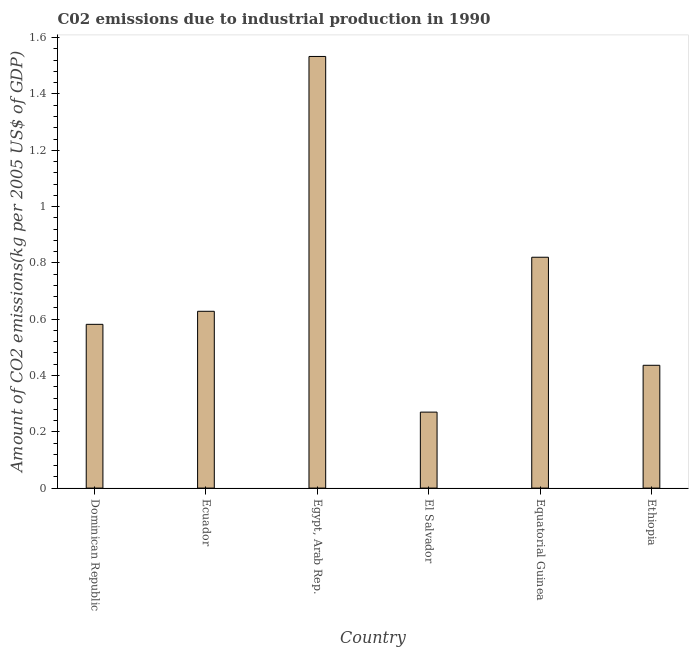Does the graph contain grids?
Give a very brief answer. No. What is the title of the graph?
Offer a terse response. C02 emissions due to industrial production in 1990. What is the label or title of the Y-axis?
Offer a very short reply. Amount of CO2 emissions(kg per 2005 US$ of GDP). What is the amount of co2 emissions in El Salvador?
Make the answer very short. 0.27. Across all countries, what is the maximum amount of co2 emissions?
Offer a very short reply. 1.53. Across all countries, what is the minimum amount of co2 emissions?
Provide a short and direct response. 0.27. In which country was the amount of co2 emissions maximum?
Ensure brevity in your answer.  Egypt, Arab Rep. In which country was the amount of co2 emissions minimum?
Your response must be concise. El Salvador. What is the sum of the amount of co2 emissions?
Make the answer very short. 4.27. What is the difference between the amount of co2 emissions in Egypt, Arab Rep. and Equatorial Guinea?
Give a very brief answer. 0.71. What is the average amount of co2 emissions per country?
Your response must be concise. 0.71. What is the median amount of co2 emissions?
Offer a terse response. 0.6. What is the ratio of the amount of co2 emissions in Egypt, Arab Rep. to that in Ethiopia?
Ensure brevity in your answer.  3.52. What is the difference between the highest and the second highest amount of co2 emissions?
Offer a terse response. 0.71. What is the difference between the highest and the lowest amount of co2 emissions?
Make the answer very short. 1.26. In how many countries, is the amount of co2 emissions greater than the average amount of co2 emissions taken over all countries?
Keep it short and to the point. 2. How many bars are there?
Offer a very short reply. 6. Are all the bars in the graph horizontal?
Provide a short and direct response. No. What is the difference between two consecutive major ticks on the Y-axis?
Ensure brevity in your answer.  0.2. What is the Amount of CO2 emissions(kg per 2005 US$ of GDP) in Dominican Republic?
Offer a very short reply. 0.58. What is the Amount of CO2 emissions(kg per 2005 US$ of GDP) in Ecuador?
Keep it short and to the point. 0.63. What is the Amount of CO2 emissions(kg per 2005 US$ of GDP) of Egypt, Arab Rep.?
Your response must be concise. 1.53. What is the Amount of CO2 emissions(kg per 2005 US$ of GDP) in El Salvador?
Keep it short and to the point. 0.27. What is the Amount of CO2 emissions(kg per 2005 US$ of GDP) of Equatorial Guinea?
Make the answer very short. 0.82. What is the Amount of CO2 emissions(kg per 2005 US$ of GDP) in Ethiopia?
Keep it short and to the point. 0.44. What is the difference between the Amount of CO2 emissions(kg per 2005 US$ of GDP) in Dominican Republic and Ecuador?
Ensure brevity in your answer.  -0.05. What is the difference between the Amount of CO2 emissions(kg per 2005 US$ of GDP) in Dominican Republic and Egypt, Arab Rep.?
Make the answer very short. -0.95. What is the difference between the Amount of CO2 emissions(kg per 2005 US$ of GDP) in Dominican Republic and El Salvador?
Your response must be concise. 0.31. What is the difference between the Amount of CO2 emissions(kg per 2005 US$ of GDP) in Dominican Republic and Equatorial Guinea?
Offer a very short reply. -0.24. What is the difference between the Amount of CO2 emissions(kg per 2005 US$ of GDP) in Dominican Republic and Ethiopia?
Keep it short and to the point. 0.15. What is the difference between the Amount of CO2 emissions(kg per 2005 US$ of GDP) in Ecuador and Egypt, Arab Rep.?
Provide a short and direct response. -0.91. What is the difference between the Amount of CO2 emissions(kg per 2005 US$ of GDP) in Ecuador and El Salvador?
Provide a succinct answer. 0.36. What is the difference between the Amount of CO2 emissions(kg per 2005 US$ of GDP) in Ecuador and Equatorial Guinea?
Provide a succinct answer. -0.19. What is the difference between the Amount of CO2 emissions(kg per 2005 US$ of GDP) in Ecuador and Ethiopia?
Your answer should be compact. 0.19. What is the difference between the Amount of CO2 emissions(kg per 2005 US$ of GDP) in Egypt, Arab Rep. and El Salvador?
Offer a very short reply. 1.26. What is the difference between the Amount of CO2 emissions(kg per 2005 US$ of GDP) in Egypt, Arab Rep. and Equatorial Guinea?
Give a very brief answer. 0.71. What is the difference between the Amount of CO2 emissions(kg per 2005 US$ of GDP) in Egypt, Arab Rep. and Ethiopia?
Make the answer very short. 1.1. What is the difference between the Amount of CO2 emissions(kg per 2005 US$ of GDP) in El Salvador and Equatorial Guinea?
Offer a very short reply. -0.55. What is the difference between the Amount of CO2 emissions(kg per 2005 US$ of GDP) in El Salvador and Ethiopia?
Your answer should be compact. -0.17. What is the difference between the Amount of CO2 emissions(kg per 2005 US$ of GDP) in Equatorial Guinea and Ethiopia?
Your answer should be very brief. 0.38. What is the ratio of the Amount of CO2 emissions(kg per 2005 US$ of GDP) in Dominican Republic to that in Ecuador?
Offer a terse response. 0.93. What is the ratio of the Amount of CO2 emissions(kg per 2005 US$ of GDP) in Dominican Republic to that in Egypt, Arab Rep.?
Your response must be concise. 0.38. What is the ratio of the Amount of CO2 emissions(kg per 2005 US$ of GDP) in Dominican Republic to that in El Salvador?
Offer a very short reply. 2.16. What is the ratio of the Amount of CO2 emissions(kg per 2005 US$ of GDP) in Dominican Republic to that in Equatorial Guinea?
Your answer should be very brief. 0.71. What is the ratio of the Amount of CO2 emissions(kg per 2005 US$ of GDP) in Dominican Republic to that in Ethiopia?
Make the answer very short. 1.33. What is the ratio of the Amount of CO2 emissions(kg per 2005 US$ of GDP) in Ecuador to that in Egypt, Arab Rep.?
Your response must be concise. 0.41. What is the ratio of the Amount of CO2 emissions(kg per 2005 US$ of GDP) in Ecuador to that in El Salvador?
Offer a very short reply. 2.33. What is the ratio of the Amount of CO2 emissions(kg per 2005 US$ of GDP) in Ecuador to that in Equatorial Guinea?
Keep it short and to the point. 0.77. What is the ratio of the Amount of CO2 emissions(kg per 2005 US$ of GDP) in Ecuador to that in Ethiopia?
Your response must be concise. 1.44. What is the ratio of the Amount of CO2 emissions(kg per 2005 US$ of GDP) in Egypt, Arab Rep. to that in El Salvador?
Your answer should be very brief. 5.68. What is the ratio of the Amount of CO2 emissions(kg per 2005 US$ of GDP) in Egypt, Arab Rep. to that in Equatorial Guinea?
Offer a terse response. 1.87. What is the ratio of the Amount of CO2 emissions(kg per 2005 US$ of GDP) in Egypt, Arab Rep. to that in Ethiopia?
Your answer should be very brief. 3.52. What is the ratio of the Amount of CO2 emissions(kg per 2005 US$ of GDP) in El Salvador to that in Equatorial Guinea?
Your response must be concise. 0.33. What is the ratio of the Amount of CO2 emissions(kg per 2005 US$ of GDP) in El Salvador to that in Ethiopia?
Provide a short and direct response. 0.62. What is the ratio of the Amount of CO2 emissions(kg per 2005 US$ of GDP) in Equatorial Guinea to that in Ethiopia?
Your answer should be compact. 1.88. 